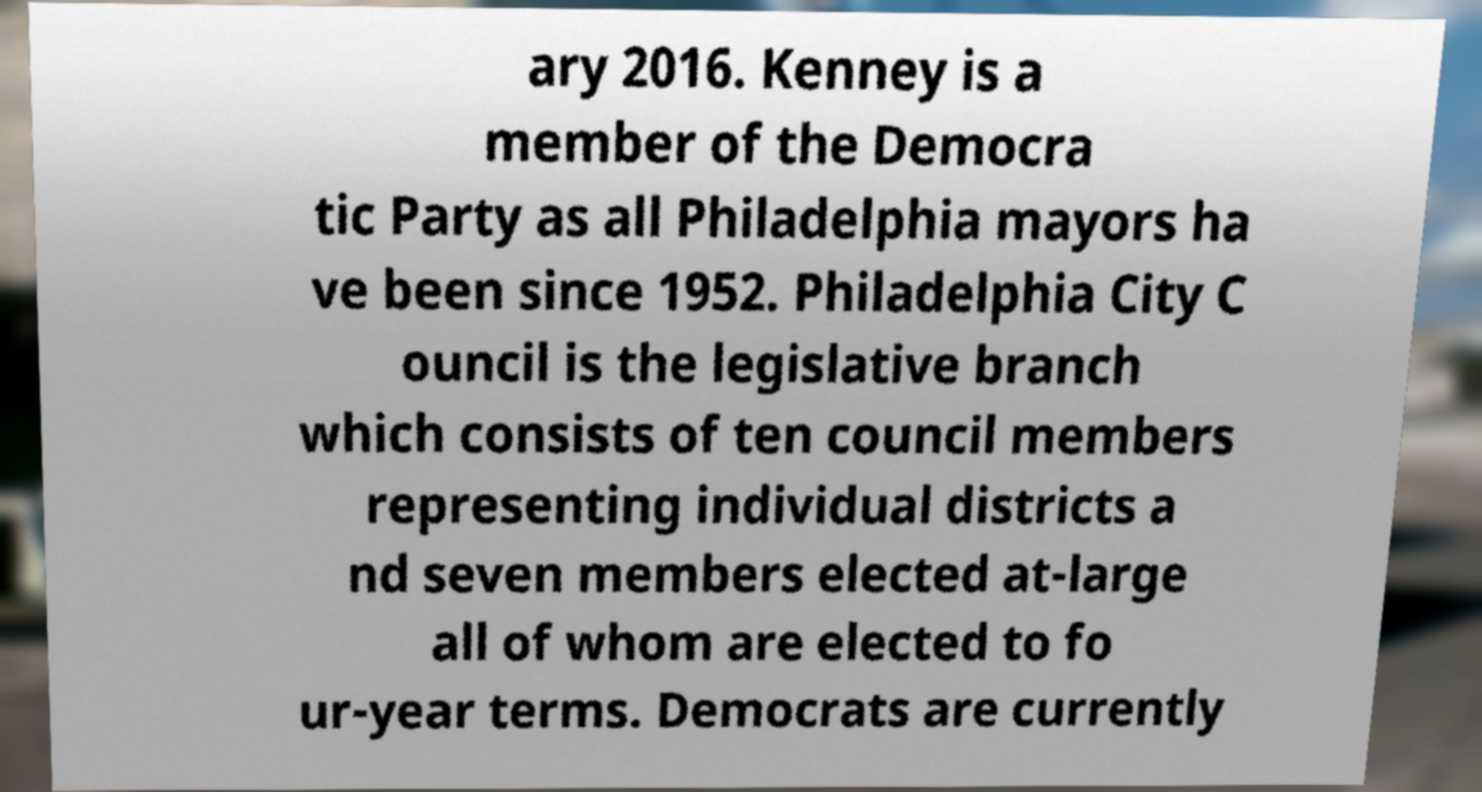Can you accurately transcribe the text from the provided image for me? ary 2016. Kenney is a member of the Democra tic Party as all Philadelphia mayors ha ve been since 1952. Philadelphia City C ouncil is the legislative branch which consists of ten council members representing individual districts a nd seven members elected at-large all of whom are elected to fo ur-year terms. Democrats are currently 